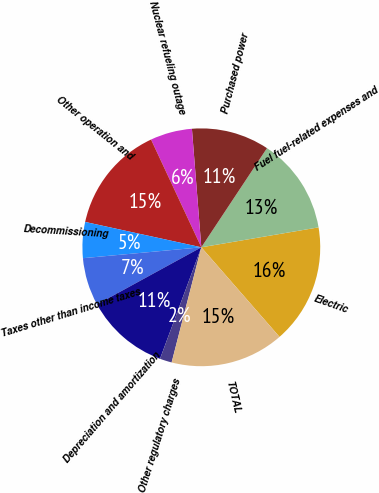Convert chart to OTSL. <chart><loc_0><loc_0><loc_500><loc_500><pie_chart><fcel>Electric<fcel>Fuel fuel-related expenses and<fcel>Purchased power<fcel>Nuclear refueling outage<fcel>Other operation and<fcel>Decommissioning<fcel>Taxes other than income taxes<fcel>Depreciation and amortization<fcel>Other regulatory charges<fcel>TOTAL<nl><fcel>16.26%<fcel>13.01%<fcel>10.57%<fcel>5.69%<fcel>14.63%<fcel>4.88%<fcel>6.51%<fcel>11.38%<fcel>1.63%<fcel>15.44%<nl></chart> 